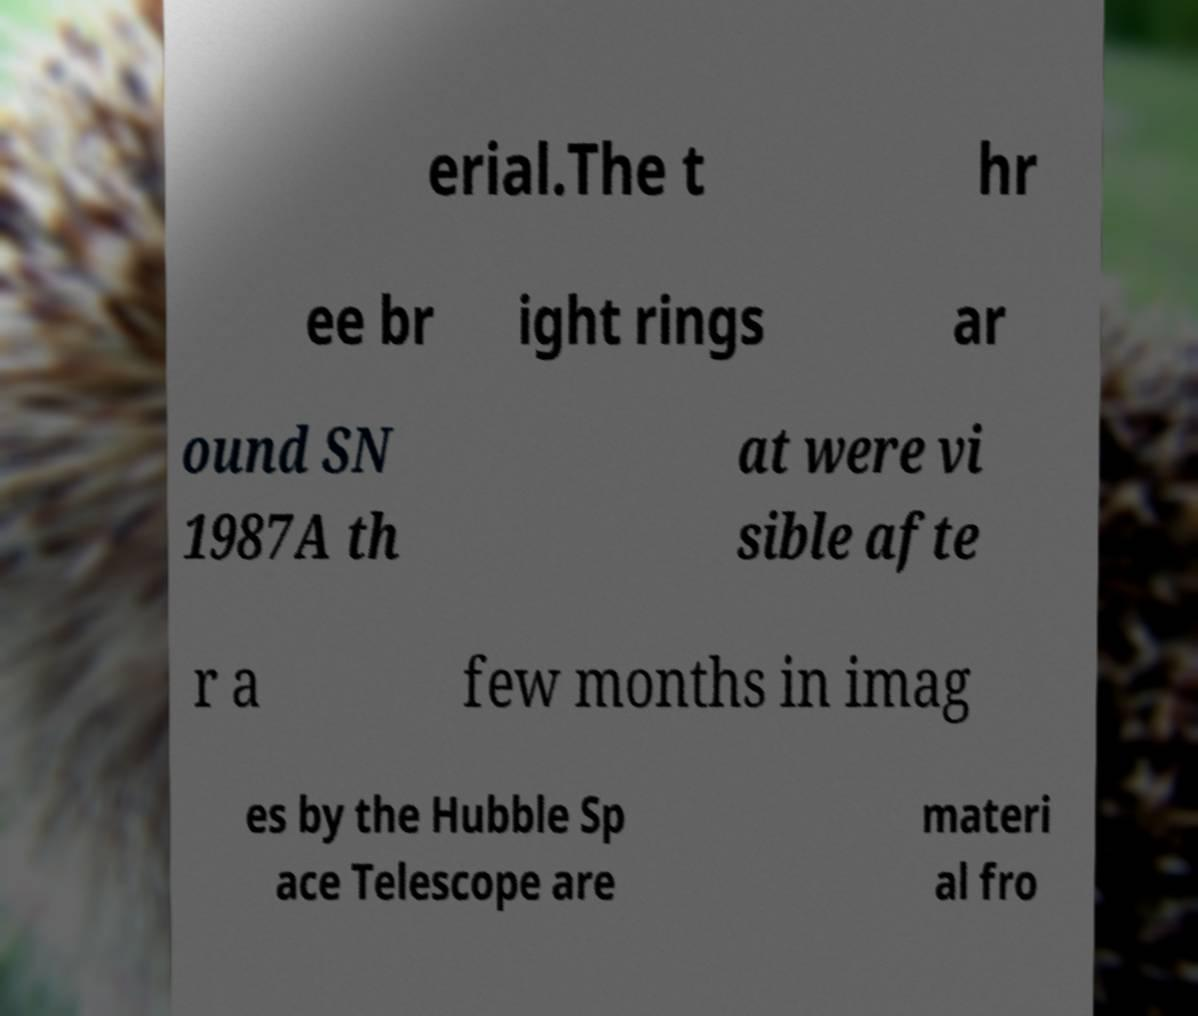I need the written content from this picture converted into text. Can you do that? erial.The t hr ee br ight rings ar ound SN 1987A th at were vi sible afte r a few months in imag es by the Hubble Sp ace Telescope are materi al fro 